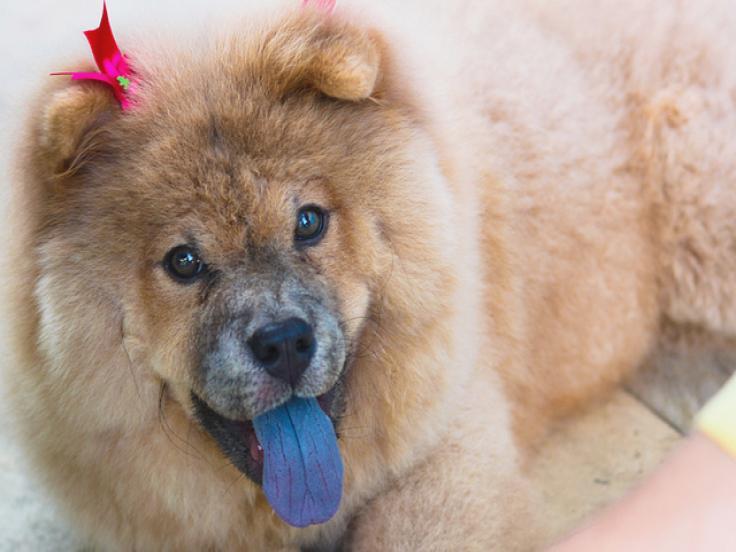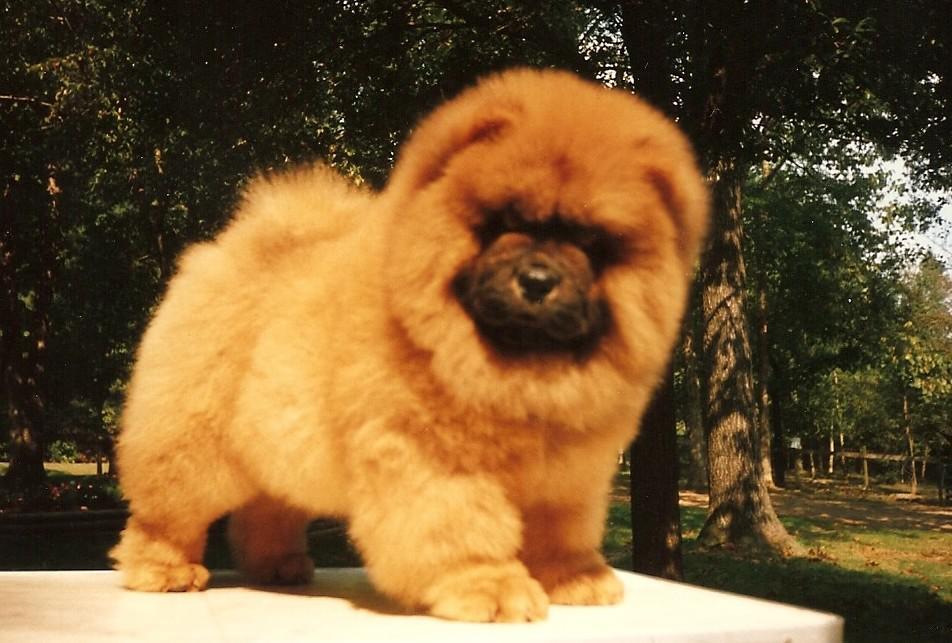The first image is the image on the left, the second image is the image on the right. For the images displayed, is the sentence "There are only two dogs." factually correct? Answer yes or no. Yes. The first image is the image on the left, the second image is the image on the right. Analyze the images presented: Is the assertion "There are no less than two dogs in each image." valid? Answer yes or no. No. 